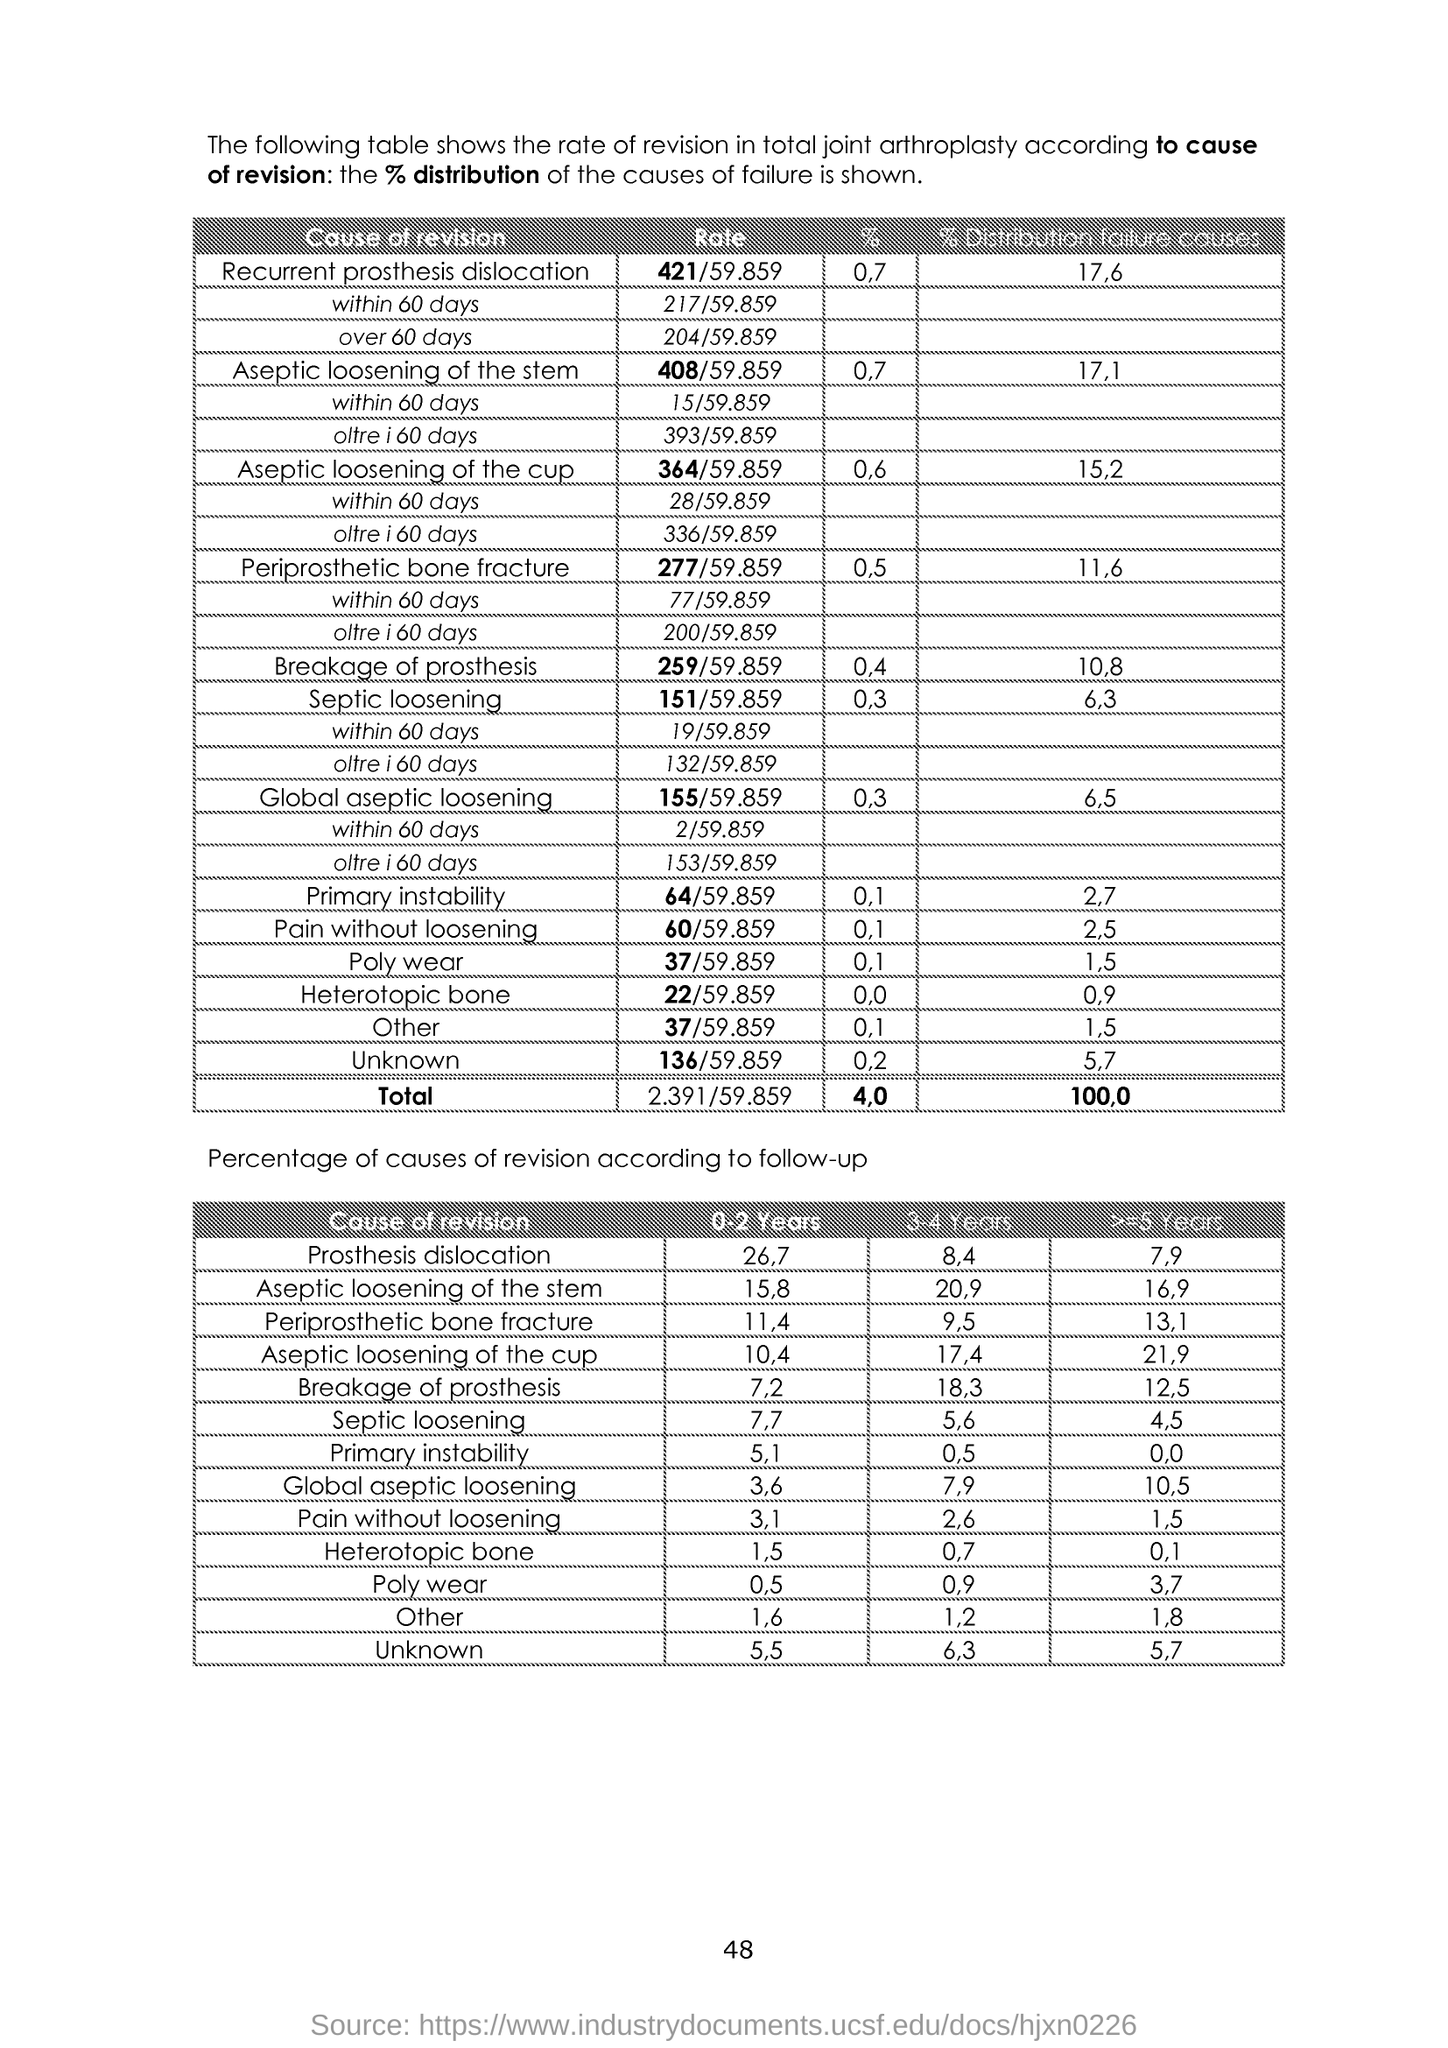What is the Page Number?
Your answer should be compact. 48. 